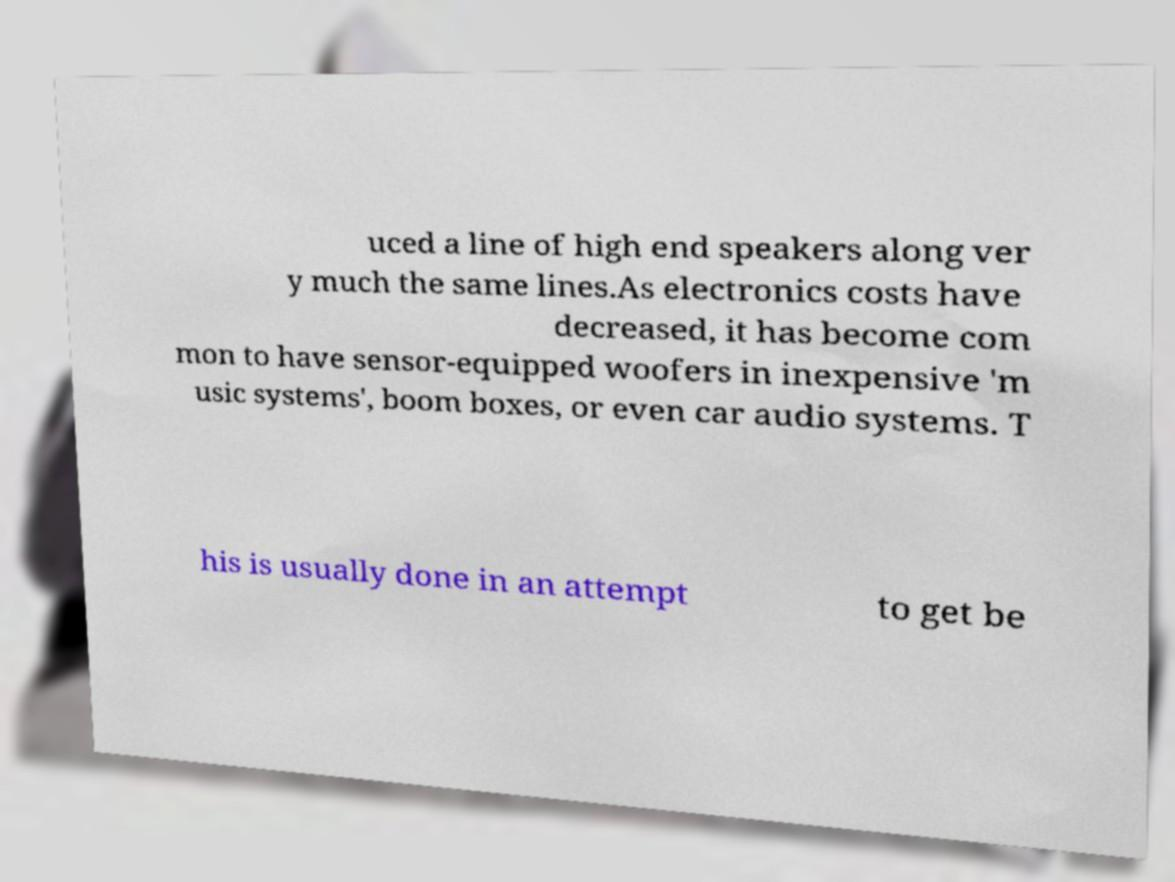Could you assist in decoding the text presented in this image and type it out clearly? uced a line of high end speakers along ver y much the same lines.As electronics costs have decreased, it has become com mon to have sensor-equipped woofers in inexpensive 'm usic systems', boom boxes, or even car audio systems. T his is usually done in an attempt to get be 